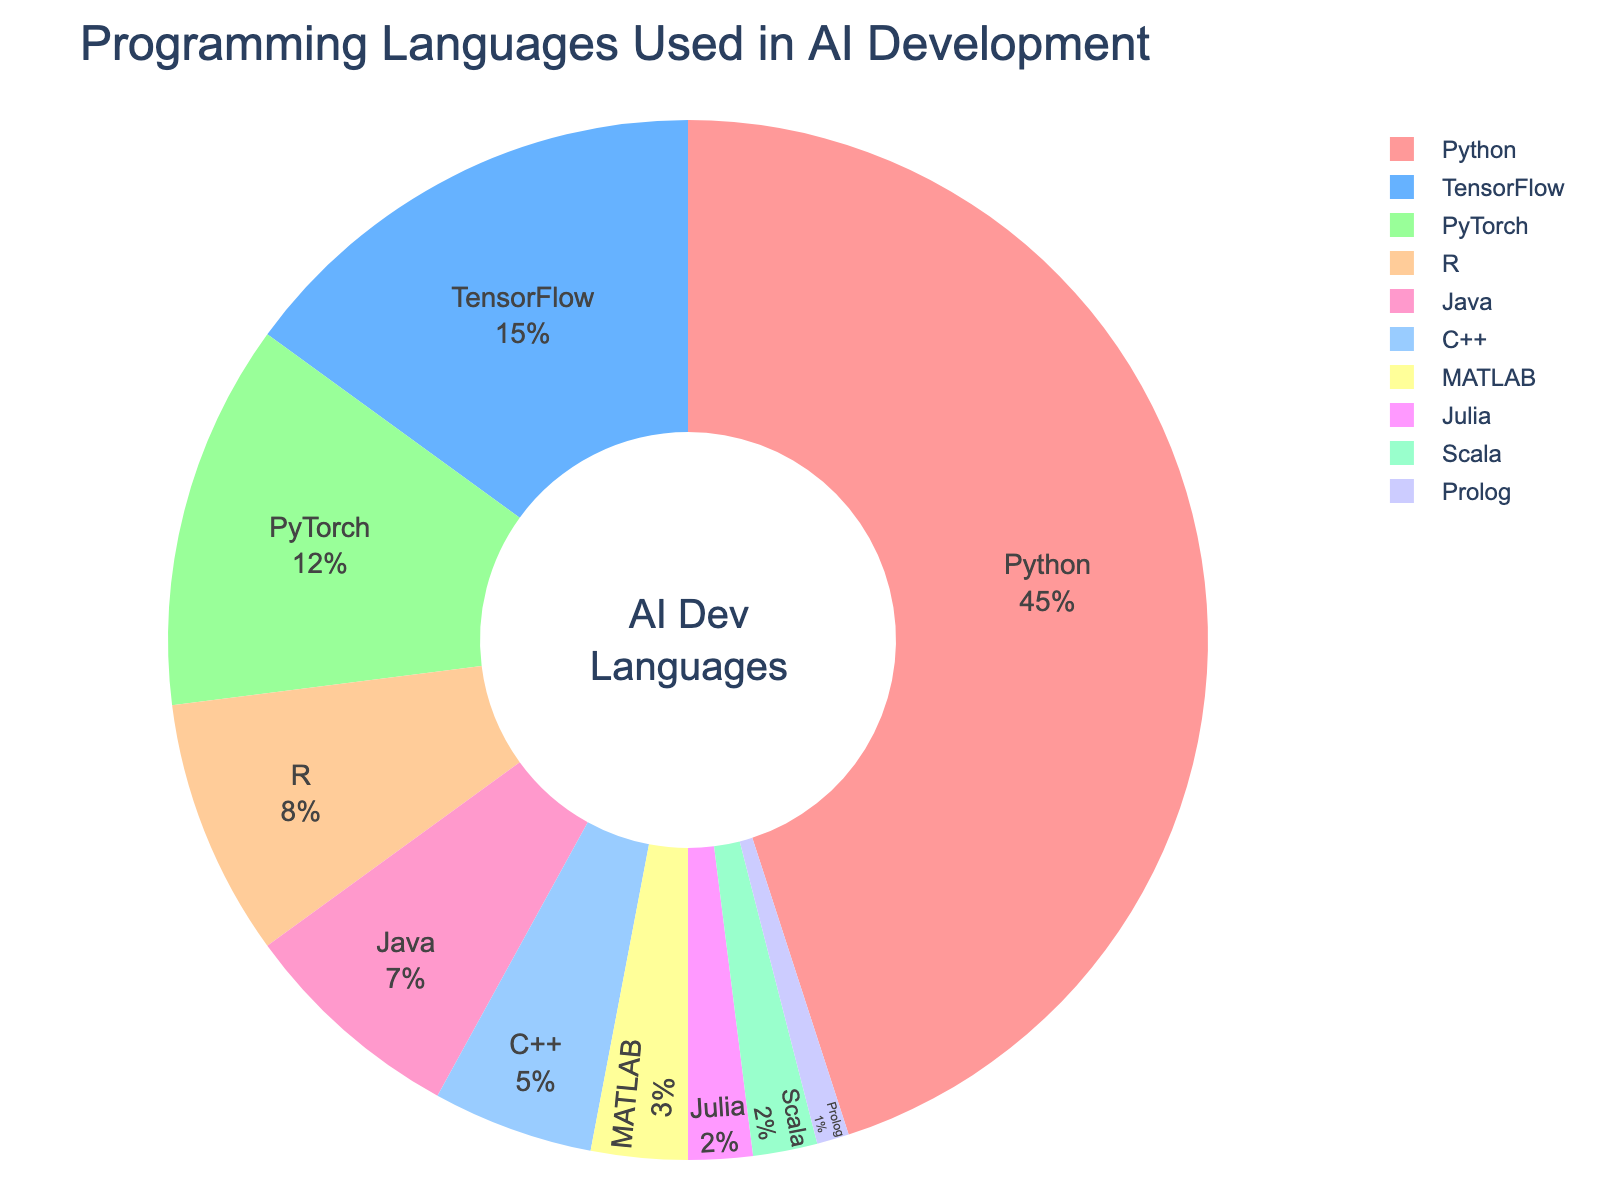Which programming language is used the most in AI development? The largest segment in the pie chart represents Python, indicating it is the most used programming language in AI development.
Answer: Python Which language has a higher percentage usage, R or Java? By comparing the segments, Java has a smaller portion compared to R. The chart lists R with 8% and Java with 7%.
Answer: R What percentage of usage do TensorFlow and PyTorch combine for? Sum the percentages of TensorFlow (15%) and PyTorch (12%), which are adjacent in the chart. 15% + 12% = 27%
Answer: 27% Which language has the smallest usage in AI development? The smallest segment in the chart corresponds to Prolog, listed with a 1% usage.
Answer: Prolog Are Python and all the languages except Python combined used more than 50% of the time in AI development? Python is 45%. Sum the percentages of all other languages (15% + 12% + 8% + 7% + 5% + 3% + 2% + 2% + 1%), which totals to 55%. Combined, they exceed 50%. 55% + 45% = 100%.
Answer: Yes Does TensorFlow have more usage than the total combined usage of C++ and Java? Compare TensorFlow's percentage (15%) to the sum of C++ (5%) and Java (7%). 5% + 7% = 12%, which is less than 15%.
Answer: Yes What is the combined percentage of the three least used languages? Sum the percentages of Matlab (3%), Julia (2%), Scala (2%), and Prolog (1%). 3% + 2% + 2% + 1% = 8%
Answer: 8% Which language is represented by the light green segment? The light green segment would logically fall under smaller percentages, but cross-referencing color zones, it represents PyTorch with 12%.
Answer: PyTorch What is the total percentage of all languages used less frequently than R? Sum the percentages of Java (7%), C++ (5%), MATLAB (3%), Julia (2%), Scala (2%), and Prolog (1%). 7% + 5% + 3% + 2% + 2% + 1% = 20%
Answer: 20% Is the median percentage usage above or below 10%? The median is the middle value in a sorted percentage list: 1%, 2%, 2%, 3%, 5%, 7%, 8%, 12%, 15%, 45%. The middle values are 5% and 7%, averaging to 6%, which is below 10%.
Answer: Below 